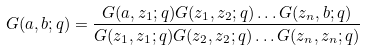Convert formula to latex. <formula><loc_0><loc_0><loc_500><loc_500>G ( a , b ; { q } ) = \frac { G ( a , z _ { 1 } ; { q } ) G ( z _ { 1 } , z _ { 2 } ; { q } ) \dots G ( z _ { n } , b ; { q } ) } { G ( z _ { 1 } , z _ { 1 } ; { q } ) G ( z _ { 2 } , z _ { 2 } ; { q } ) \dots G ( z _ { n } , z _ { n } ; { q } ) }</formula> 